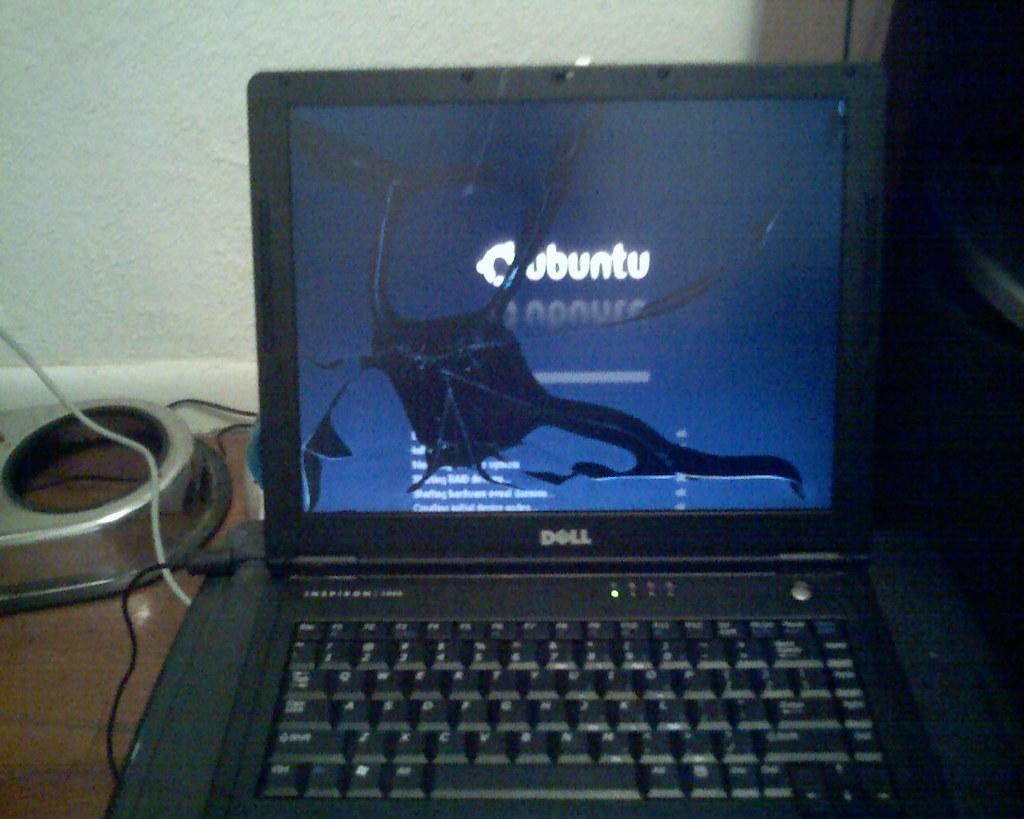<image>
Provide a brief description of the given image. A Dell laptop computer displays an Ubuntu site behind a cracked screen. 